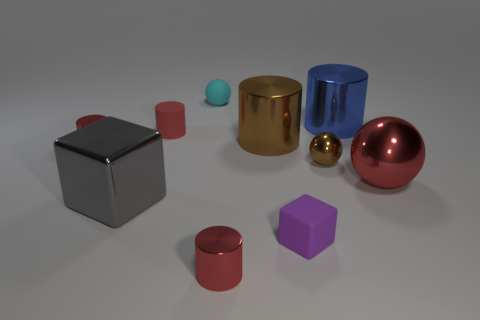How many small objects have the same material as the big red ball?
Your response must be concise. 3. What number of objects are metal objects behind the big red metal thing or purple rubber balls?
Provide a succinct answer. 4. The gray object is what size?
Give a very brief answer. Large. The red object that is right of the red metallic cylinder to the right of the small cyan object is made of what material?
Your response must be concise. Metal. Is the size of the red metallic cylinder that is in front of the gray object the same as the red shiny sphere?
Your answer should be compact. No. Are there any large metal cylinders that have the same color as the small shiny sphere?
Your answer should be compact. Yes. What number of things are tiny red metallic things on the left side of the large gray shiny cube or shiny objects that are right of the matte cube?
Offer a terse response. 4. Is the color of the big cube the same as the rubber cube?
Provide a short and direct response. No. There is a cylinder that is the same color as the small metal ball; what is its material?
Keep it short and to the point. Metal. Are there fewer small metallic cylinders that are behind the tiny rubber sphere than small metal cylinders to the right of the small metal ball?
Offer a terse response. No. 